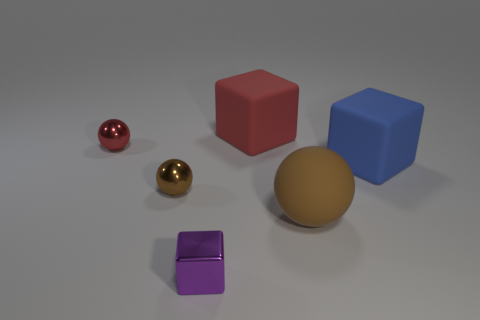Subtract all gray cylinders. How many brown spheres are left? 2 Subtract all matte blocks. How many blocks are left? 1 Add 3 shiny cylinders. How many objects exist? 9 Subtract all gray balls. Subtract all gray cylinders. How many balls are left? 3 Subtract all big red rubber things. Subtract all brown spheres. How many objects are left? 3 Add 4 tiny things. How many tiny things are left? 7 Add 5 large shiny spheres. How many large shiny spheres exist? 5 Subtract 0 red cylinders. How many objects are left? 6 